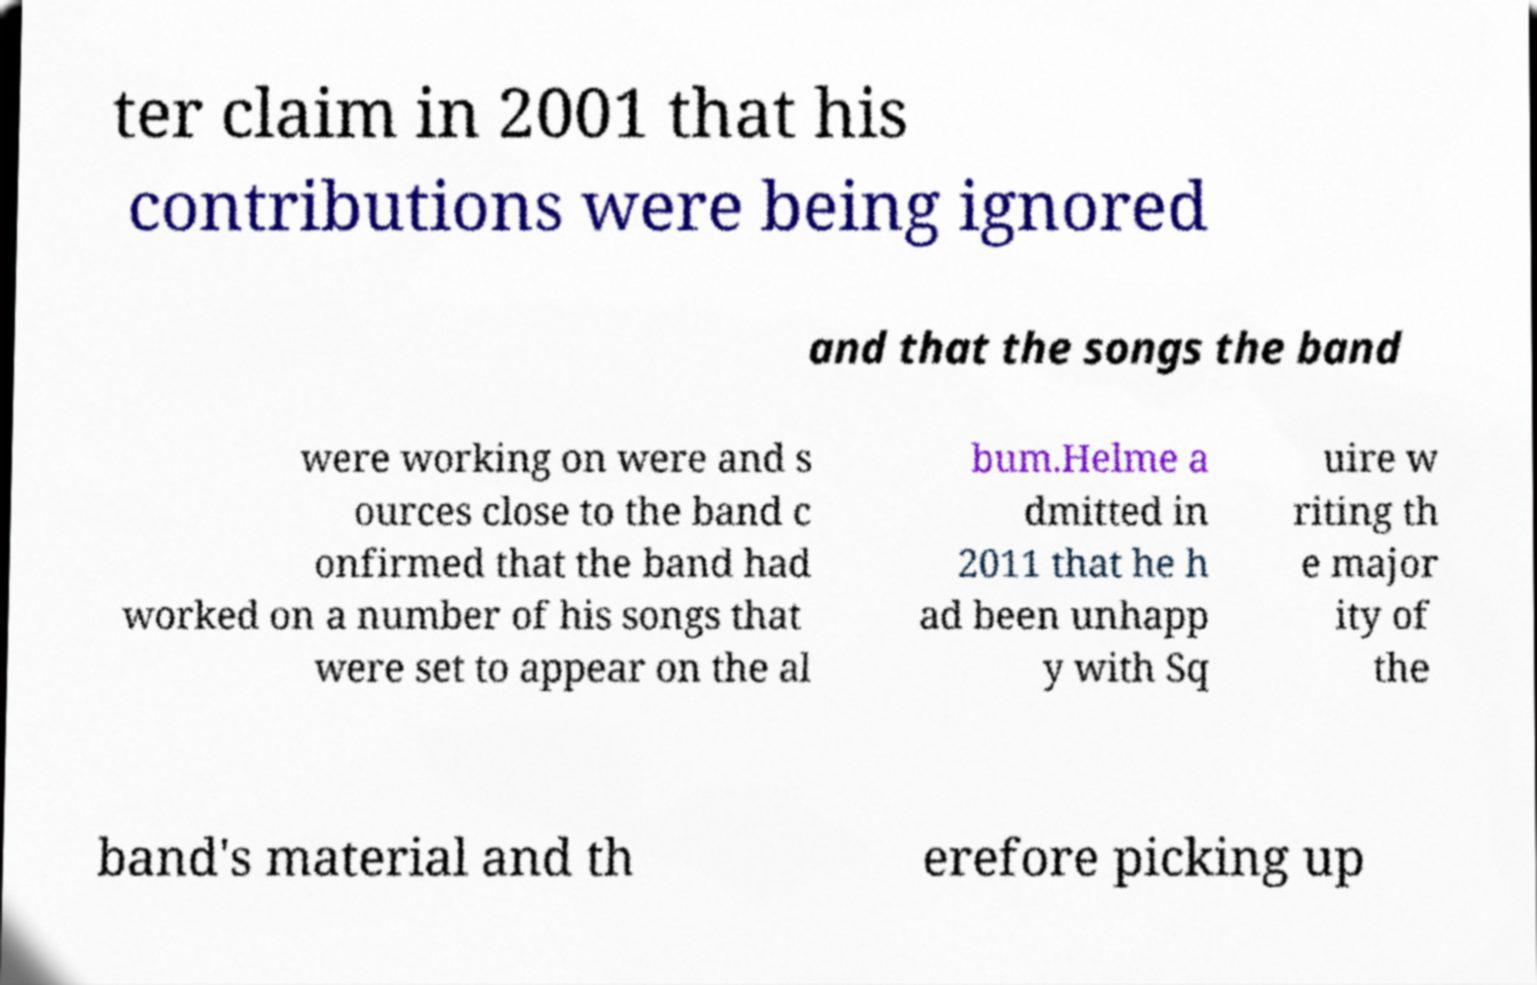Please identify and transcribe the text found in this image. ter claim in 2001 that his contributions were being ignored and that the songs the band were working on were and s ources close to the band c onfirmed that the band had worked on a number of his songs that were set to appear on the al bum.Helme a dmitted in 2011 that he h ad been unhapp y with Sq uire w riting th e major ity of the band's material and th erefore picking up 